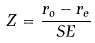<formula> <loc_0><loc_0><loc_500><loc_500>Z = \frac { r _ { o } - r _ { e } } { S E }</formula> 